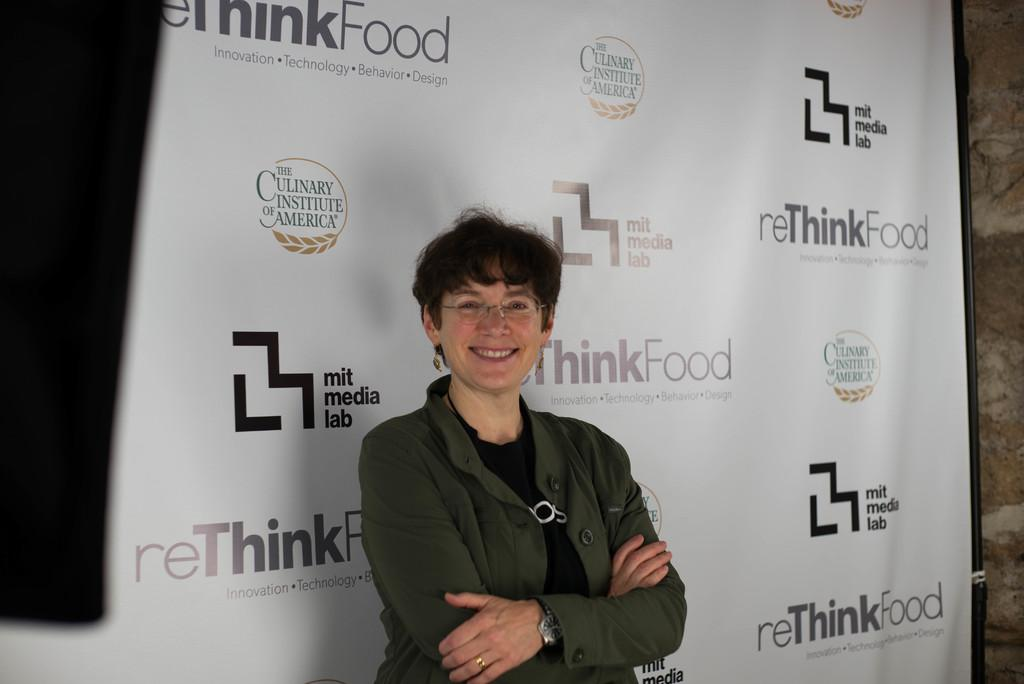What is the woman in the image doing? The woman is standing in the image. What is the woman wearing in the image? The woman is wearing a coat and spectacles in the image. What is the woman's facial expression in the image? The woman is smiling in the image. What can be seen in the background of the image? There is a banner in the background of the image. What is written on the banner in the image? There is text written on the banner in the image. Can you see any sand or swimming activities in the image? No, there is no sand or swimming activities present in the image. Is there a frog visible in the image? No, there is no frog visible in the image. 